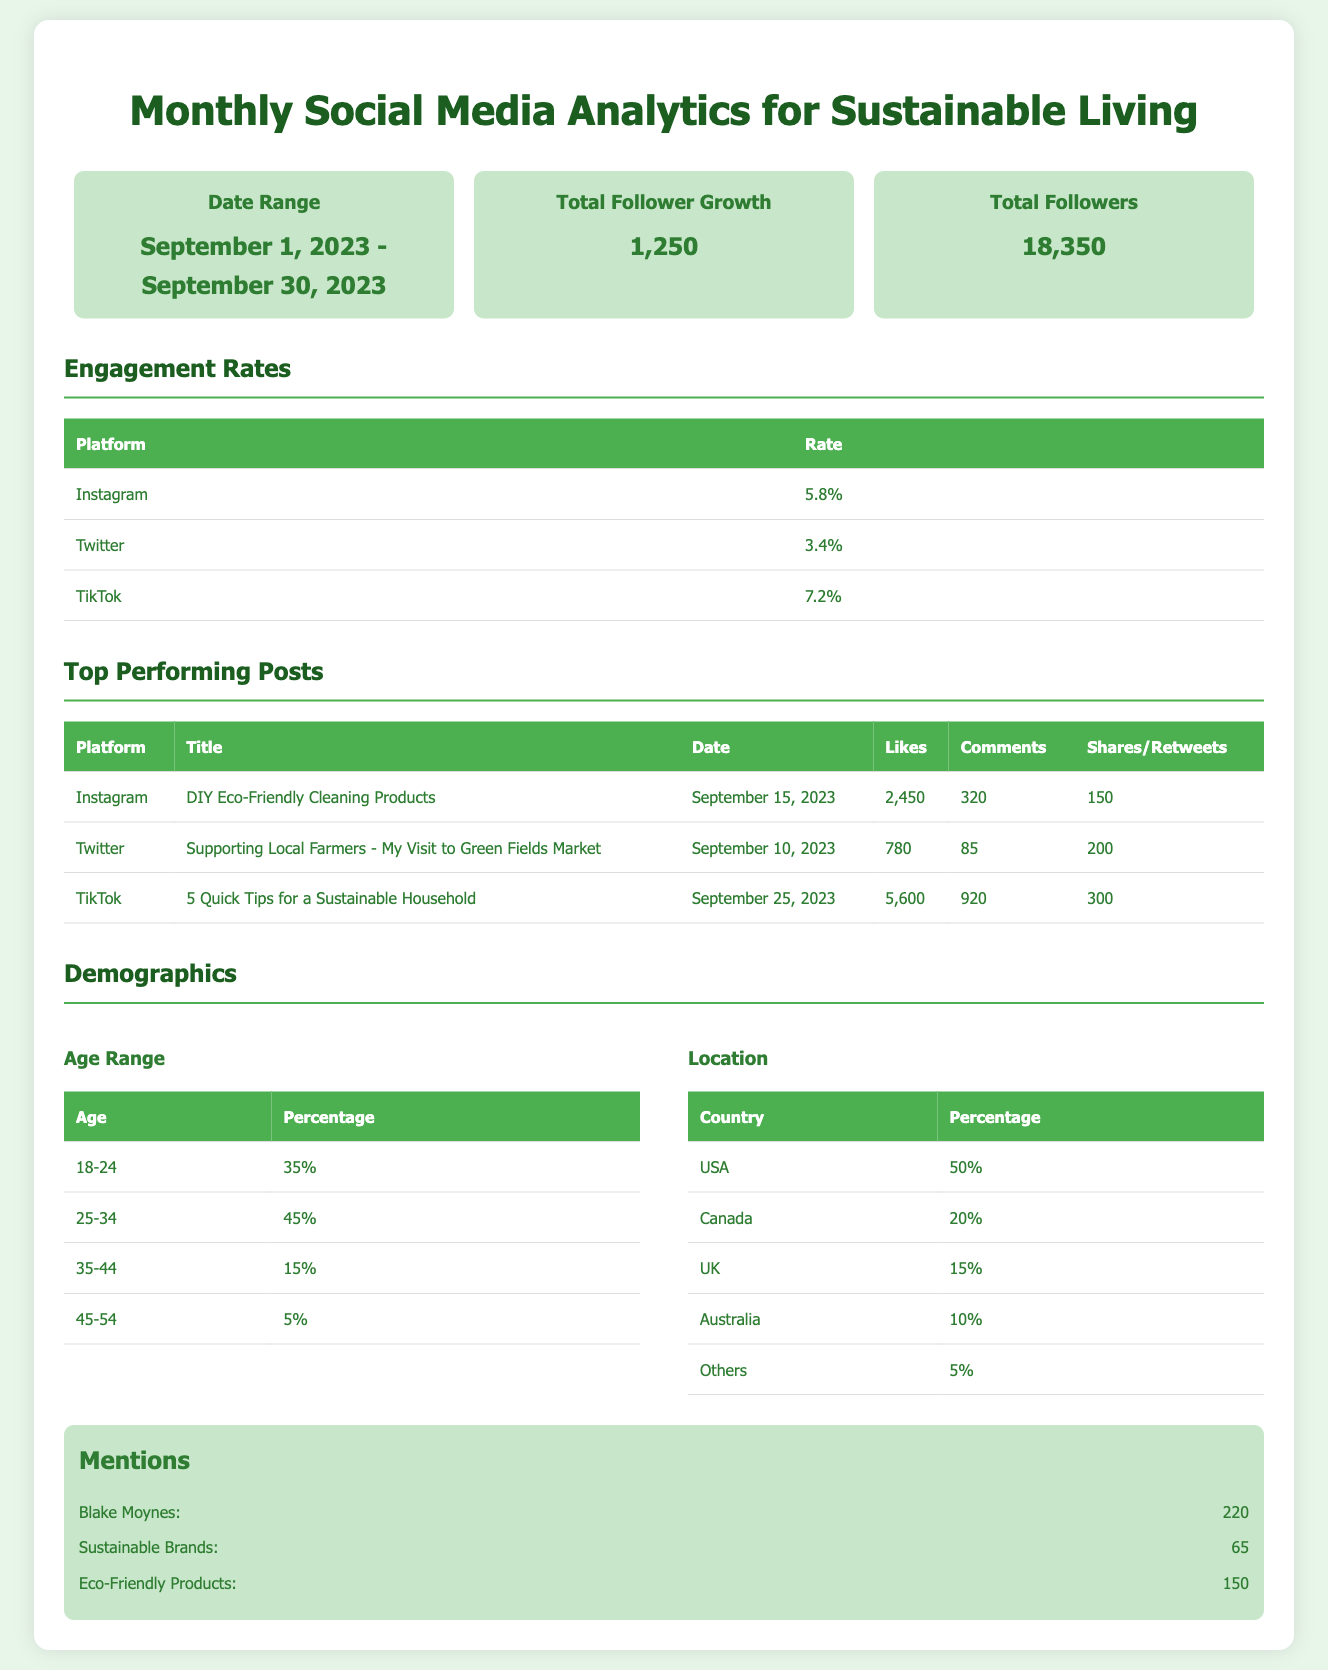What is the date range for the analytics? The date range is mentioned in the summary section, which shows the months of September 1, 2023, to September 30, 2023.
Answer: September 1, 2023 - September 30, 2023 What is the total follower growth for the month? The total follower growth is provided in the summary, which indicates an increase of 1,250 followers over the month.
Answer: 1,250 Which platform had the highest engagement rate? The engagement rates table lists Instagram, Twitter, and TikTok, with TikTok having the highest rate of 7.2%.
Answer: TikTok What post generated the most likes in September? The top-performing posts section shows that the TikTok post titled "5 Quick Tips for a Sustainable Household" received 5,600 likes, the highest in the month.
Answer: 5,600 What percentage of followers are aged 25-34? The demographic section provides age ranges, indicating that 45% of followers belong to the 25-34 age range.
Answer: 45% Which country has the highest percentage of followers? The demographics table shows that the USA accounts for 50% of the followers, making it the highest.
Answer: USA How many mentions did Blake Moynes receive? The mentions section lists the number of mentions for Blake Moynes as 220 during the reporting period.
Answer: 220 What was the total number of comments on the top Instagram post? According to the top-performing posts table, the Instagram post received 320 comments, which is the total for that specific post.
Answer: 320 